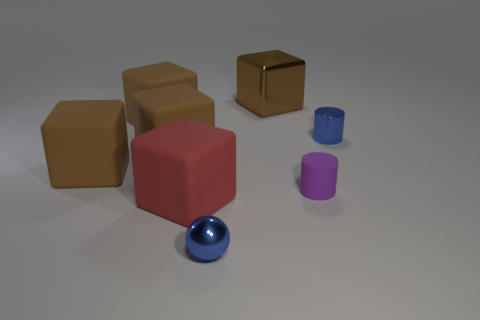Is the number of brown rubber blocks that are behind the tiny metallic cylinder greater than the number of small metal things to the right of the tiny metallic sphere?
Make the answer very short. No. The brown cube that is made of the same material as the small blue cylinder is what size?
Your answer should be compact. Large. There is a small blue thing behind the big red matte object; what number of tiny cylinders are to the right of it?
Your answer should be very brief. 0. Are there any other red rubber objects of the same shape as the red rubber thing?
Your answer should be compact. No. The matte object right of the blue thing on the left side of the purple object is what color?
Offer a terse response. Purple. Is the number of large brown rubber things greater than the number of large red matte things?
Keep it short and to the point. Yes. What number of blue metallic cylinders have the same size as the metal cube?
Offer a very short reply. 0. Do the big red thing and the small purple cylinder that is to the right of the tiny ball have the same material?
Keep it short and to the point. Yes. Are there fewer small purple rubber cylinders than brown rubber blocks?
Your answer should be compact. Yes. Are there any other things of the same color as the small matte cylinder?
Offer a terse response. No. 